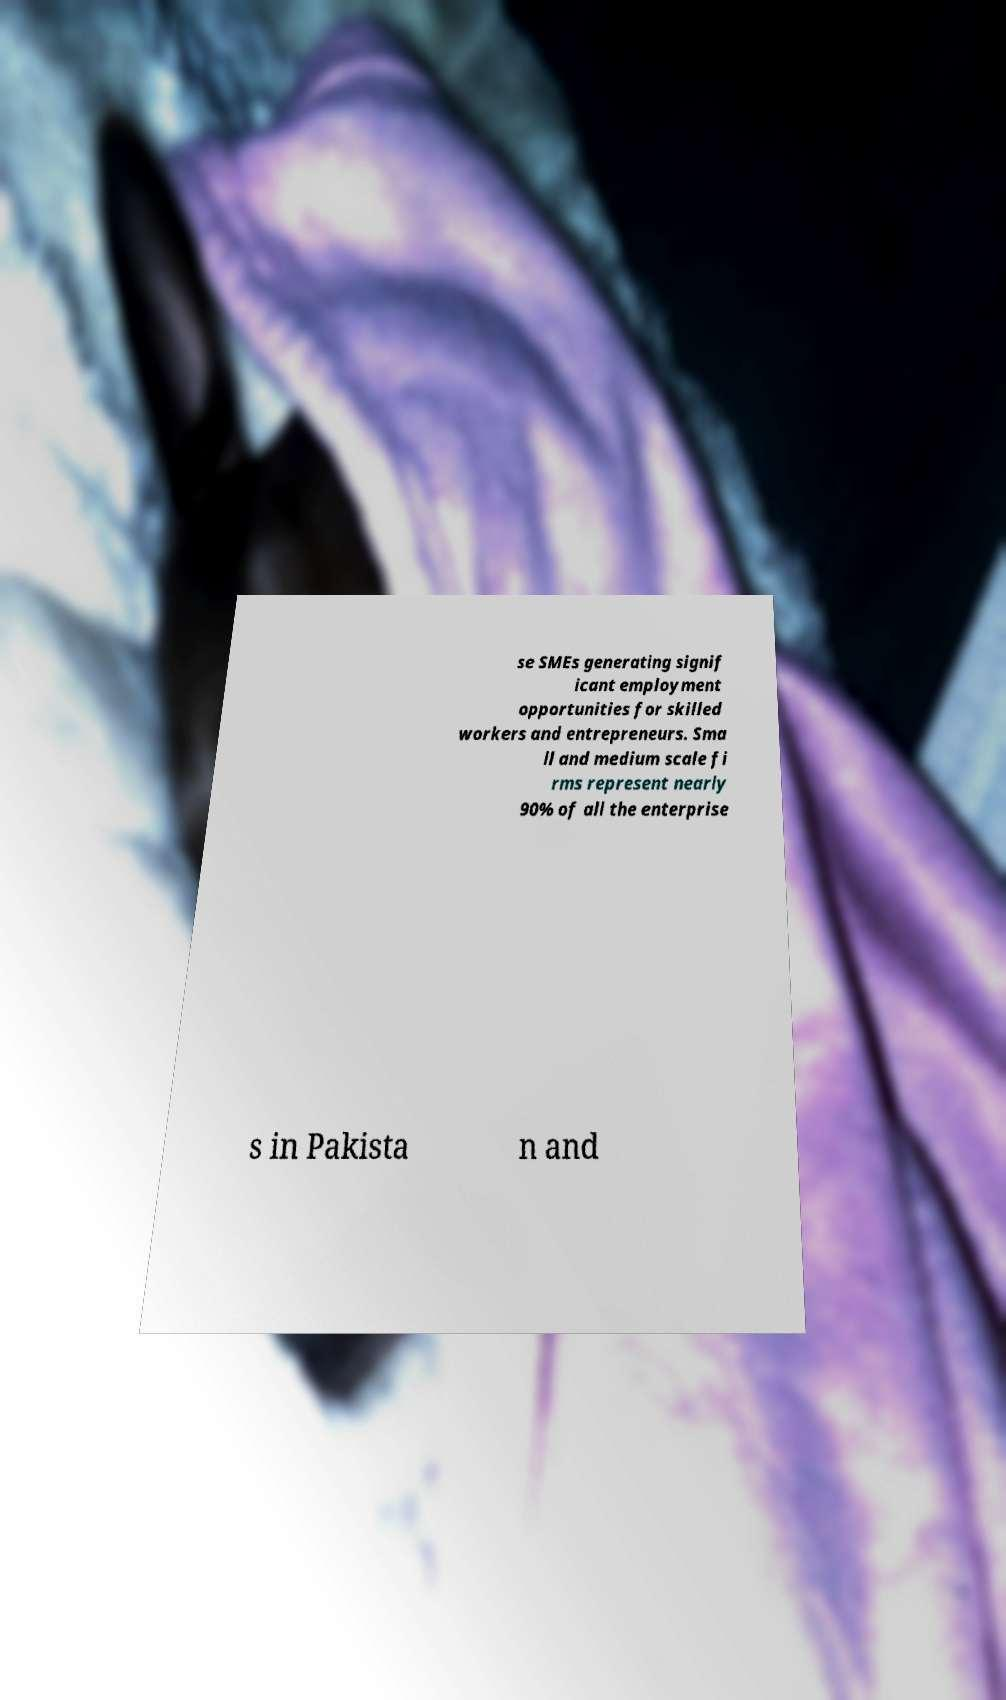Can you accurately transcribe the text from the provided image for me? se SMEs generating signif icant employment opportunities for skilled workers and entrepreneurs. Sma ll and medium scale fi rms represent nearly 90% of all the enterprise s in Pakista n and 